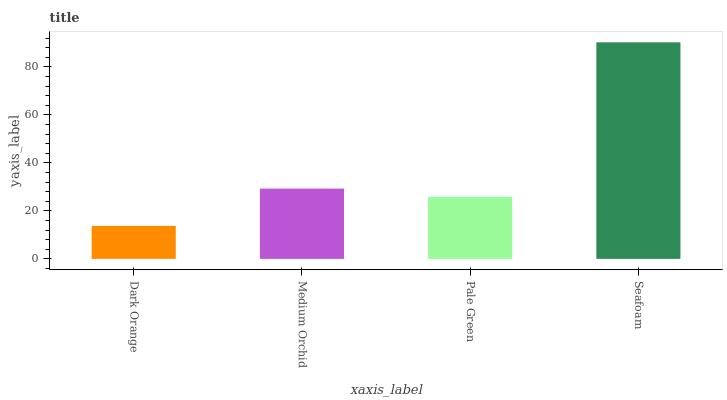Is Dark Orange the minimum?
Answer yes or no. Yes. Is Seafoam the maximum?
Answer yes or no. Yes. Is Medium Orchid the minimum?
Answer yes or no. No. Is Medium Orchid the maximum?
Answer yes or no. No. Is Medium Orchid greater than Dark Orange?
Answer yes or no. Yes. Is Dark Orange less than Medium Orchid?
Answer yes or no. Yes. Is Dark Orange greater than Medium Orchid?
Answer yes or no. No. Is Medium Orchid less than Dark Orange?
Answer yes or no. No. Is Medium Orchid the high median?
Answer yes or no. Yes. Is Pale Green the low median?
Answer yes or no. Yes. Is Seafoam the high median?
Answer yes or no. No. Is Medium Orchid the low median?
Answer yes or no. No. 